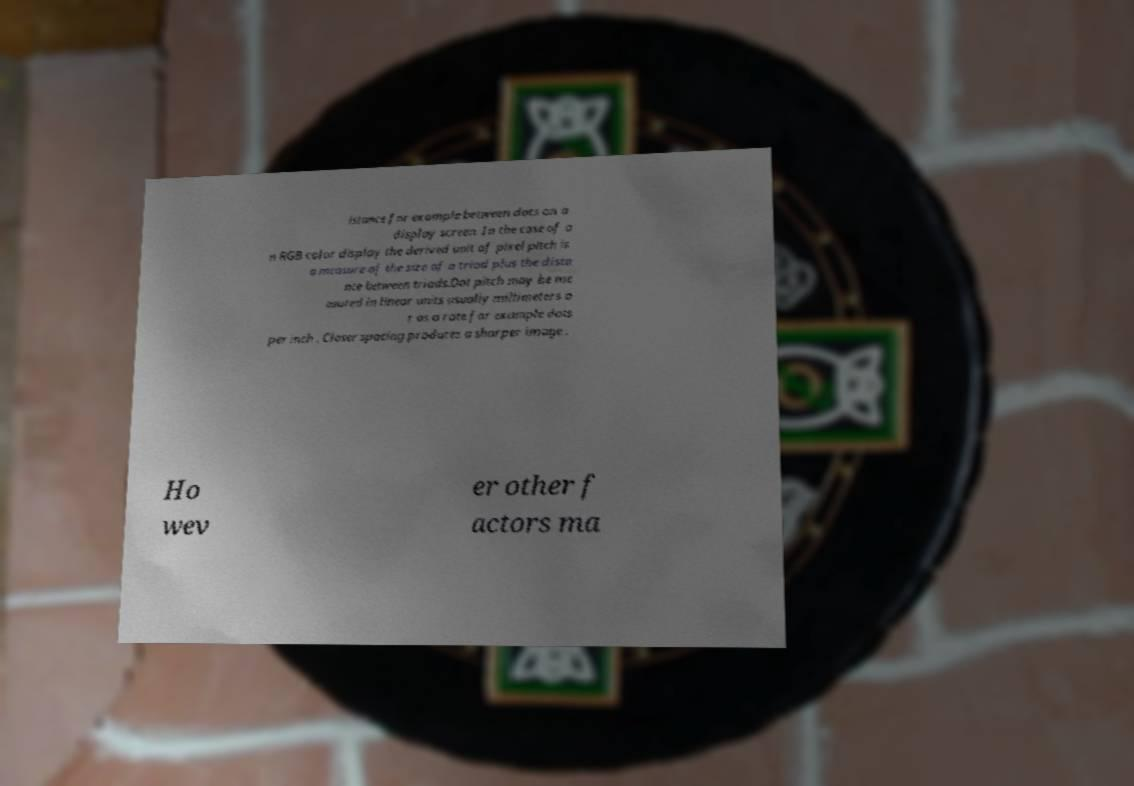Could you assist in decoding the text presented in this image and type it out clearly? istance for example between dots on a display screen. In the case of a n RGB color display the derived unit of pixel pitch is a measure of the size of a triad plus the dista nce between triads.Dot pitch may be me asured in linear units usually millimeters o r as a rate for example dots per inch . Closer spacing produces a sharper image . Ho wev er other f actors ma 